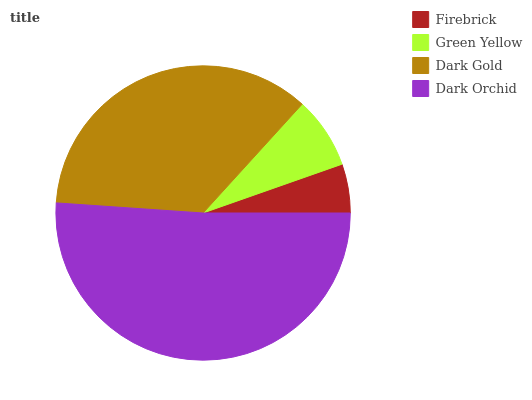Is Firebrick the minimum?
Answer yes or no. Yes. Is Dark Orchid the maximum?
Answer yes or no. Yes. Is Green Yellow the minimum?
Answer yes or no. No. Is Green Yellow the maximum?
Answer yes or no. No. Is Green Yellow greater than Firebrick?
Answer yes or no. Yes. Is Firebrick less than Green Yellow?
Answer yes or no. Yes. Is Firebrick greater than Green Yellow?
Answer yes or no. No. Is Green Yellow less than Firebrick?
Answer yes or no. No. Is Dark Gold the high median?
Answer yes or no. Yes. Is Green Yellow the low median?
Answer yes or no. Yes. Is Dark Orchid the high median?
Answer yes or no. No. Is Firebrick the low median?
Answer yes or no. No. 